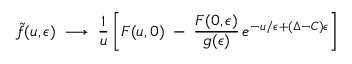Convert formula to latex. <formula><loc_0><loc_0><loc_500><loc_500>\widetilde { f } ( u , \epsilon ) \, \longrightarrow \, { \frac { 1 } { u } } \left [ F ( u , 0 ) \, - \, { \frac { F ( 0 , \epsilon ) } { g ( \epsilon ) } } \, e ^ { - u / \epsilon + ( \Delta - C ) \epsilon } \right ] \,</formula> 